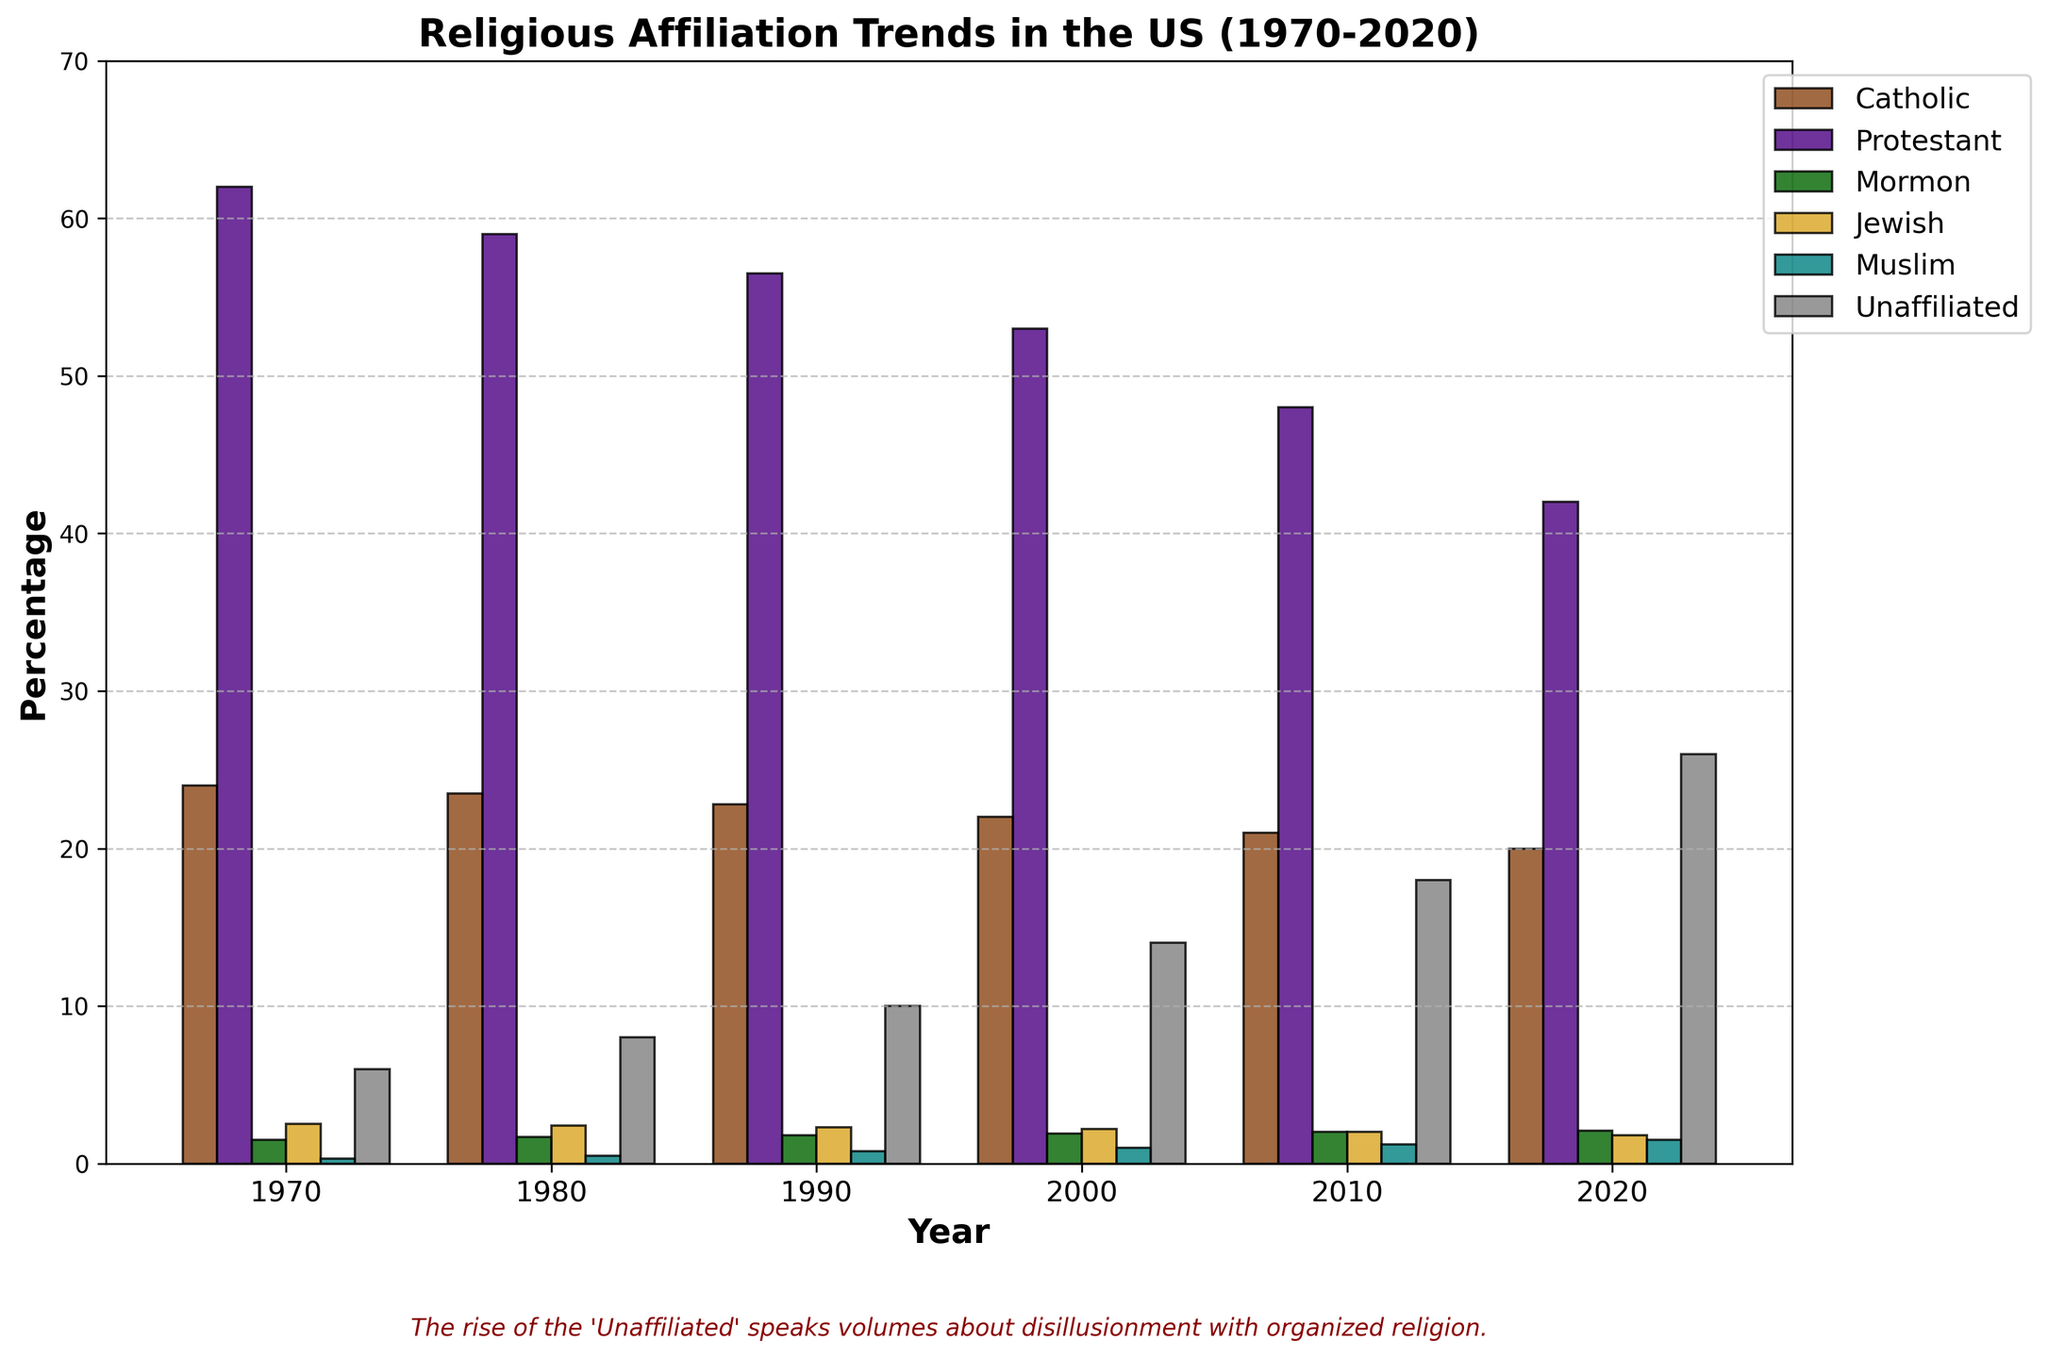what percentage of the population was Unaffiliated in 2020? In 2020, the height of the bar for the Unaffiliated category corresponds to the data point given for Unaffiliated in 2020, which is 26.
Answer: 26% Which denomination saw the greatest decline between 1970 and 2020? Compare the heights of the bars for each denomination between 1970 and 2020. Protestant dropped from 62.0 to 42.0, which is the largest decrease in percentage points.
Answer: Protestant How much did the Muslim population increase from 1970 to 2020? Subtract the percentage in 1970 (0.3) from the percentage in 2020 (1.5). So, 1.5 - 0.3 = 1.2.
Answer: 1.2% Which denomination had a consistent increase over the entire 50 years? Check the bars for each denomination across all years and identify which bars increase continuously. The Mormon and Muslim denominations show consistent increases.
Answer: Mormon and Muslim In what year did the Unaffiliated group surpass 10%? Look at the bar heights for the Unaffiliated category across the years. In 1990, the Unaffiliated group reached 10%.
Answer: 1990 What is the sum of the percentages of Catholic and Protestant groups in 2010? Add the percentages for Catholic (21.0) and Protestant (48.0) in 2010. So, 21.0 + 48.0 = 69.0
Answer: 69.0 Between which decades did the Protestant denomination see the largest drop? Compare the drop in percentages for each decade: 1970-1980, 1980-1990, 1990-2000, 2000-2010, and 2010-2020. The largest drop is between 2000 and 2010, from 53.0 to 48.0, a 5.0% drop.
Answer: 2000 to 2010 What does the text below the chart suggest about the overall trend? The text at the bottom comments on the rise of the 'Unaffiliated', indicating a significant increase in people disillusioned with organized religion.
Answer: Rise of Unaffiliated and disillusionment 